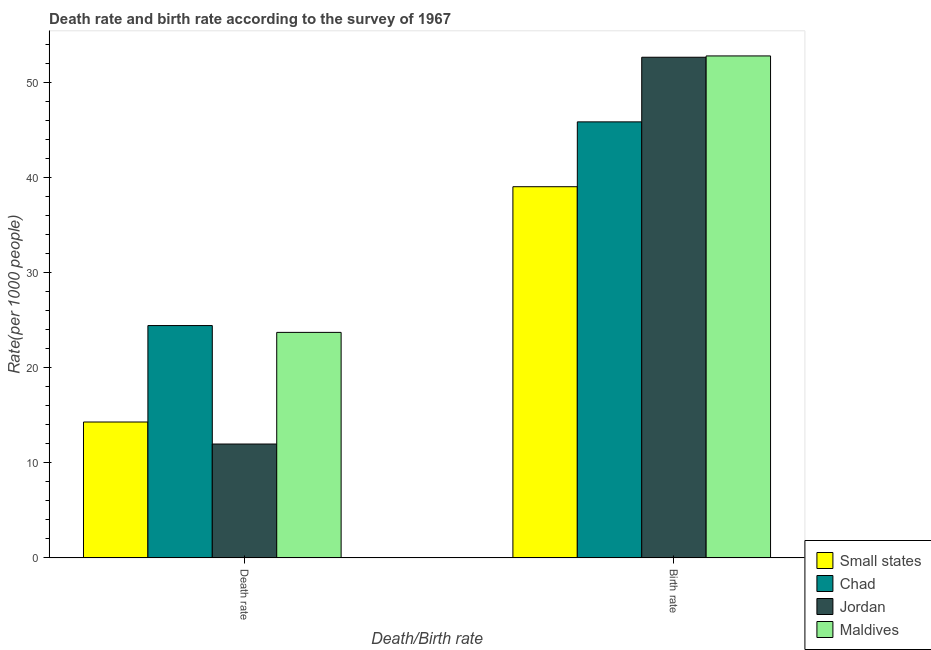How many groups of bars are there?
Your answer should be very brief. 2. Are the number of bars per tick equal to the number of legend labels?
Your response must be concise. Yes. Are the number of bars on each tick of the X-axis equal?
Offer a very short reply. Yes. How many bars are there on the 1st tick from the left?
Make the answer very short. 4. What is the label of the 2nd group of bars from the left?
Give a very brief answer. Birth rate. What is the birth rate in Chad?
Your response must be concise. 45.85. Across all countries, what is the maximum birth rate?
Your answer should be compact. 52.79. Across all countries, what is the minimum death rate?
Offer a very short reply. 11.97. In which country was the death rate maximum?
Offer a very short reply. Chad. In which country was the death rate minimum?
Offer a terse response. Jordan. What is the total birth rate in the graph?
Offer a very short reply. 190.32. What is the difference between the birth rate in Small states and that in Maldives?
Offer a terse response. -13.75. What is the difference between the death rate in Jordan and the birth rate in Small states?
Your response must be concise. -27.06. What is the average death rate per country?
Provide a short and direct response. 18.6. What is the difference between the birth rate and death rate in Maldives?
Give a very brief answer. 29.07. In how many countries, is the birth rate greater than 38 ?
Ensure brevity in your answer.  4. What is the ratio of the birth rate in Small states to that in Chad?
Provide a succinct answer. 0.85. Is the birth rate in Jordan less than that in Chad?
Your answer should be very brief. No. In how many countries, is the death rate greater than the average death rate taken over all countries?
Your answer should be compact. 2. What does the 4th bar from the left in Birth rate represents?
Ensure brevity in your answer.  Maldives. What does the 2nd bar from the right in Death rate represents?
Offer a terse response. Jordan. How many countries are there in the graph?
Give a very brief answer. 4. What is the difference between two consecutive major ticks on the Y-axis?
Make the answer very short. 10. Where does the legend appear in the graph?
Provide a short and direct response. Bottom right. How many legend labels are there?
Provide a short and direct response. 4. How are the legend labels stacked?
Offer a very short reply. Vertical. What is the title of the graph?
Provide a succinct answer. Death rate and birth rate according to the survey of 1967. What is the label or title of the X-axis?
Your response must be concise. Death/Birth rate. What is the label or title of the Y-axis?
Provide a succinct answer. Rate(per 1000 people). What is the Rate(per 1000 people) of Small states in Death rate?
Make the answer very short. 14.29. What is the Rate(per 1000 people) in Chad in Death rate?
Give a very brief answer. 24.43. What is the Rate(per 1000 people) in Jordan in Death rate?
Provide a short and direct response. 11.97. What is the Rate(per 1000 people) of Maldives in Death rate?
Make the answer very short. 23.71. What is the Rate(per 1000 people) in Small states in Birth rate?
Your response must be concise. 39.03. What is the Rate(per 1000 people) in Chad in Birth rate?
Keep it short and to the point. 45.85. What is the Rate(per 1000 people) in Jordan in Birth rate?
Your answer should be very brief. 52.65. What is the Rate(per 1000 people) of Maldives in Birth rate?
Give a very brief answer. 52.79. Across all Death/Birth rate, what is the maximum Rate(per 1000 people) in Small states?
Your answer should be very brief. 39.03. Across all Death/Birth rate, what is the maximum Rate(per 1000 people) in Chad?
Your response must be concise. 45.85. Across all Death/Birth rate, what is the maximum Rate(per 1000 people) of Jordan?
Offer a very short reply. 52.65. Across all Death/Birth rate, what is the maximum Rate(per 1000 people) in Maldives?
Offer a terse response. 52.79. Across all Death/Birth rate, what is the minimum Rate(per 1000 people) in Small states?
Provide a short and direct response. 14.29. Across all Death/Birth rate, what is the minimum Rate(per 1000 people) in Chad?
Your answer should be very brief. 24.43. Across all Death/Birth rate, what is the minimum Rate(per 1000 people) of Jordan?
Offer a very short reply. 11.97. Across all Death/Birth rate, what is the minimum Rate(per 1000 people) of Maldives?
Make the answer very short. 23.71. What is the total Rate(per 1000 people) in Small states in the graph?
Your answer should be compact. 53.32. What is the total Rate(per 1000 people) of Chad in the graph?
Your answer should be very brief. 70.28. What is the total Rate(per 1000 people) in Jordan in the graph?
Offer a terse response. 64.62. What is the total Rate(per 1000 people) in Maldives in the graph?
Give a very brief answer. 76.5. What is the difference between the Rate(per 1000 people) of Small states in Death rate and that in Birth rate?
Your answer should be compact. -24.74. What is the difference between the Rate(per 1000 people) in Chad in Death rate and that in Birth rate?
Provide a short and direct response. -21.42. What is the difference between the Rate(per 1000 people) of Jordan in Death rate and that in Birth rate?
Provide a short and direct response. -40.67. What is the difference between the Rate(per 1000 people) of Maldives in Death rate and that in Birth rate?
Provide a short and direct response. -29.07. What is the difference between the Rate(per 1000 people) of Small states in Death rate and the Rate(per 1000 people) of Chad in Birth rate?
Your answer should be compact. -31.56. What is the difference between the Rate(per 1000 people) of Small states in Death rate and the Rate(per 1000 people) of Jordan in Birth rate?
Your answer should be compact. -38.36. What is the difference between the Rate(per 1000 people) of Small states in Death rate and the Rate(per 1000 people) of Maldives in Birth rate?
Offer a terse response. -38.5. What is the difference between the Rate(per 1000 people) in Chad in Death rate and the Rate(per 1000 people) in Jordan in Birth rate?
Your response must be concise. -28.22. What is the difference between the Rate(per 1000 people) of Chad in Death rate and the Rate(per 1000 people) of Maldives in Birth rate?
Provide a succinct answer. -28.35. What is the difference between the Rate(per 1000 people) of Jordan in Death rate and the Rate(per 1000 people) of Maldives in Birth rate?
Your answer should be compact. -40.81. What is the average Rate(per 1000 people) in Small states per Death/Birth rate?
Give a very brief answer. 26.66. What is the average Rate(per 1000 people) of Chad per Death/Birth rate?
Your answer should be very brief. 35.14. What is the average Rate(per 1000 people) of Jordan per Death/Birth rate?
Offer a terse response. 32.31. What is the average Rate(per 1000 people) in Maldives per Death/Birth rate?
Offer a terse response. 38.25. What is the difference between the Rate(per 1000 people) of Small states and Rate(per 1000 people) of Chad in Death rate?
Keep it short and to the point. -10.14. What is the difference between the Rate(per 1000 people) of Small states and Rate(per 1000 people) of Jordan in Death rate?
Give a very brief answer. 2.32. What is the difference between the Rate(per 1000 people) in Small states and Rate(per 1000 people) in Maldives in Death rate?
Provide a succinct answer. -9.42. What is the difference between the Rate(per 1000 people) in Chad and Rate(per 1000 people) in Jordan in Death rate?
Make the answer very short. 12.46. What is the difference between the Rate(per 1000 people) of Chad and Rate(per 1000 people) of Maldives in Death rate?
Keep it short and to the point. 0.72. What is the difference between the Rate(per 1000 people) of Jordan and Rate(per 1000 people) of Maldives in Death rate?
Offer a very short reply. -11.74. What is the difference between the Rate(per 1000 people) of Small states and Rate(per 1000 people) of Chad in Birth rate?
Offer a terse response. -6.82. What is the difference between the Rate(per 1000 people) in Small states and Rate(per 1000 people) in Jordan in Birth rate?
Ensure brevity in your answer.  -13.62. What is the difference between the Rate(per 1000 people) of Small states and Rate(per 1000 people) of Maldives in Birth rate?
Keep it short and to the point. -13.75. What is the difference between the Rate(per 1000 people) in Chad and Rate(per 1000 people) in Jordan in Birth rate?
Provide a succinct answer. -6.8. What is the difference between the Rate(per 1000 people) of Chad and Rate(per 1000 people) of Maldives in Birth rate?
Offer a very short reply. -6.93. What is the difference between the Rate(per 1000 people) in Jordan and Rate(per 1000 people) in Maldives in Birth rate?
Your answer should be very brief. -0.14. What is the ratio of the Rate(per 1000 people) in Small states in Death rate to that in Birth rate?
Keep it short and to the point. 0.37. What is the ratio of the Rate(per 1000 people) in Chad in Death rate to that in Birth rate?
Offer a very short reply. 0.53. What is the ratio of the Rate(per 1000 people) of Jordan in Death rate to that in Birth rate?
Ensure brevity in your answer.  0.23. What is the ratio of the Rate(per 1000 people) in Maldives in Death rate to that in Birth rate?
Your answer should be very brief. 0.45. What is the difference between the highest and the second highest Rate(per 1000 people) of Small states?
Make the answer very short. 24.74. What is the difference between the highest and the second highest Rate(per 1000 people) of Chad?
Ensure brevity in your answer.  21.42. What is the difference between the highest and the second highest Rate(per 1000 people) in Jordan?
Ensure brevity in your answer.  40.67. What is the difference between the highest and the second highest Rate(per 1000 people) of Maldives?
Make the answer very short. 29.07. What is the difference between the highest and the lowest Rate(per 1000 people) of Small states?
Your response must be concise. 24.74. What is the difference between the highest and the lowest Rate(per 1000 people) of Chad?
Your response must be concise. 21.42. What is the difference between the highest and the lowest Rate(per 1000 people) in Jordan?
Your answer should be compact. 40.67. What is the difference between the highest and the lowest Rate(per 1000 people) in Maldives?
Make the answer very short. 29.07. 